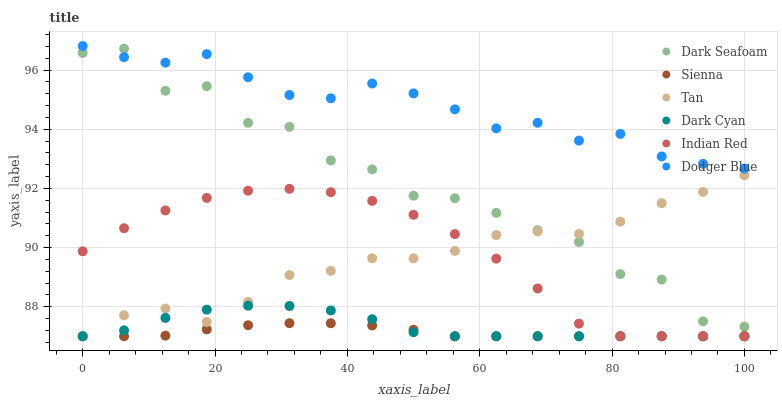Does Sienna have the minimum area under the curve?
Answer yes or no. Yes. Does Dodger Blue have the maximum area under the curve?
Answer yes or no. Yes. Does Dark Seafoam have the minimum area under the curve?
Answer yes or no. No. Does Dark Seafoam have the maximum area under the curve?
Answer yes or no. No. Is Sienna the smoothest?
Answer yes or no. Yes. Is Dark Seafoam the roughest?
Answer yes or no. Yes. Is Dodger Blue the smoothest?
Answer yes or no. No. Is Dodger Blue the roughest?
Answer yes or no. No. Does Sienna have the lowest value?
Answer yes or no. Yes. Does Dark Seafoam have the lowest value?
Answer yes or no. No. Does Dodger Blue have the highest value?
Answer yes or no. Yes. Does Dark Seafoam have the highest value?
Answer yes or no. No. Is Sienna less than Dodger Blue?
Answer yes or no. Yes. Is Dark Seafoam greater than Sienna?
Answer yes or no. Yes. Does Dark Seafoam intersect Tan?
Answer yes or no. Yes. Is Dark Seafoam less than Tan?
Answer yes or no. No. Is Dark Seafoam greater than Tan?
Answer yes or no. No. Does Sienna intersect Dodger Blue?
Answer yes or no. No. 